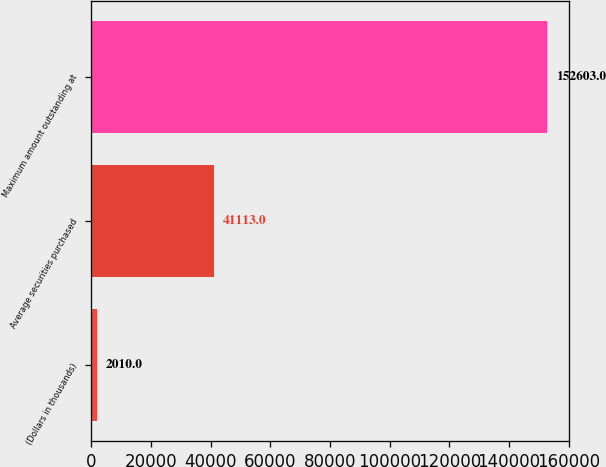<chart> <loc_0><loc_0><loc_500><loc_500><bar_chart><fcel>(Dollars in thousands)<fcel>Average securities purchased<fcel>Maximum amount outstanding at<nl><fcel>2010<fcel>41113<fcel>152603<nl></chart> 